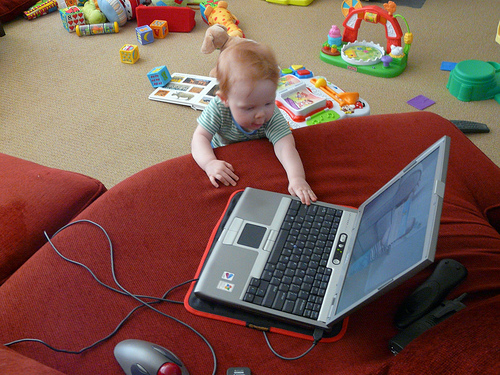<image>
Is the baby on the cushion? Yes. Looking at the image, I can see the baby is positioned on top of the cushion, with the cushion providing support. Where is the kid in relation to the laptop? Is it on the laptop? No. The kid is not positioned on the laptop. They may be near each other, but the kid is not supported by or resting on top of the laptop. Is there a baby in the laptop? No. The baby is not contained within the laptop. These objects have a different spatial relationship. Is the laptop in front of the baby? Yes. The laptop is positioned in front of the baby, appearing closer to the camera viewpoint. 